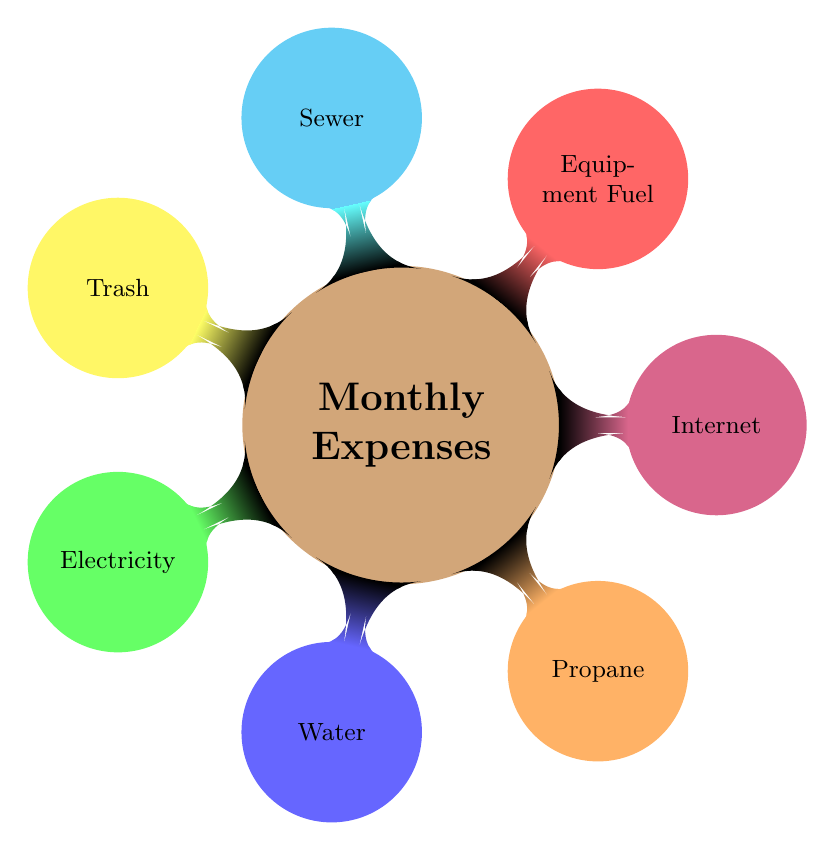What is the main topic of the diagram? The main topic of the diagram is indicated by the central node labeled "Monthly Expenses." This node encapsulates the overall theme of the diagram, which is focused on the monthly utility expenses for a typical farming household.
Answer: Monthly Expenses How many different utility expenses are broken down in the diagram? By counting the child nodes connected to the main topic ("Monthly Expenses"), we find a total of seven nodes. Each child node represents a different utility expense, providing a complete breakdown.
Answer: Seven Which utility expense is associated with energy? The utility expense related to energy can be identified by the node labeled "Electricity." This node specifically represents the cost associated with electrical energy consumption.
Answer: Electricity What color is the node for "Water"? The node labeled "Water" is colored blue, as indicated by the color coding used throughout the diagram to distinguish between different utility expenses.
Answer: Blue Which two utility expenses are colored orange and red, respectively? The utility expense in orange is "Propane," and the one in red is "Equipment Fuel." These specific colors help differentiate the various categories of expenses visually.
Answer: Propane and Equipment Fuel How is the "Internet" utility expense categorized in the diagram? The "Internet" expense is represented by the node colored purple. This categorization signifies its distinct nature compared to other utility expenses, such as electricity and water.
Answer: Purple If we consider only the colored nodes, which utility expenses are connected to the category of sanitation? The connection to sanitation is represented by the "Sewer" utility expense, which is depicted in cyan in the diagram. This node highlights the sanitation-related monthly utility costs.
Answer: Sewer Which node has the lowest position in the diagram? The lowest position in the diagram is held by the child nodes related to utility expenses, specifically the node labeled "Trash." Although all expenses are on the same level, it is often visually perceived as the lowest due to its position in the layout.
Answer: Trash What is the significance of the central node in the diagram? The central node serves as the main focus point, encapsulating the primary theme of monthly utility expenses. It provides context for all the child nodes, which represent individual expense categories stemming from this central idea.
Answer: Main focus point 